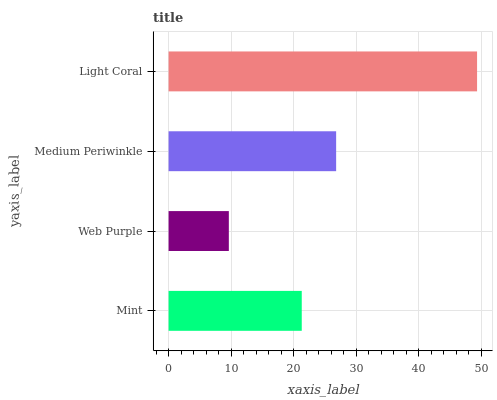Is Web Purple the minimum?
Answer yes or no. Yes. Is Light Coral the maximum?
Answer yes or no. Yes. Is Medium Periwinkle the minimum?
Answer yes or no. No. Is Medium Periwinkle the maximum?
Answer yes or no. No. Is Medium Periwinkle greater than Web Purple?
Answer yes or no. Yes. Is Web Purple less than Medium Periwinkle?
Answer yes or no. Yes. Is Web Purple greater than Medium Periwinkle?
Answer yes or no. No. Is Medium Periwinkle less than Web Purple?
Answer yes or no. No. Is Medium Periwinkle the high median?
Answer yes or no. Yes. Is Mint the low median?
Answer yes or no. Yes. Is Mint the high median?
Answer yes or no. No. Is Light Coral the low median?
Answer yes or no. No. 